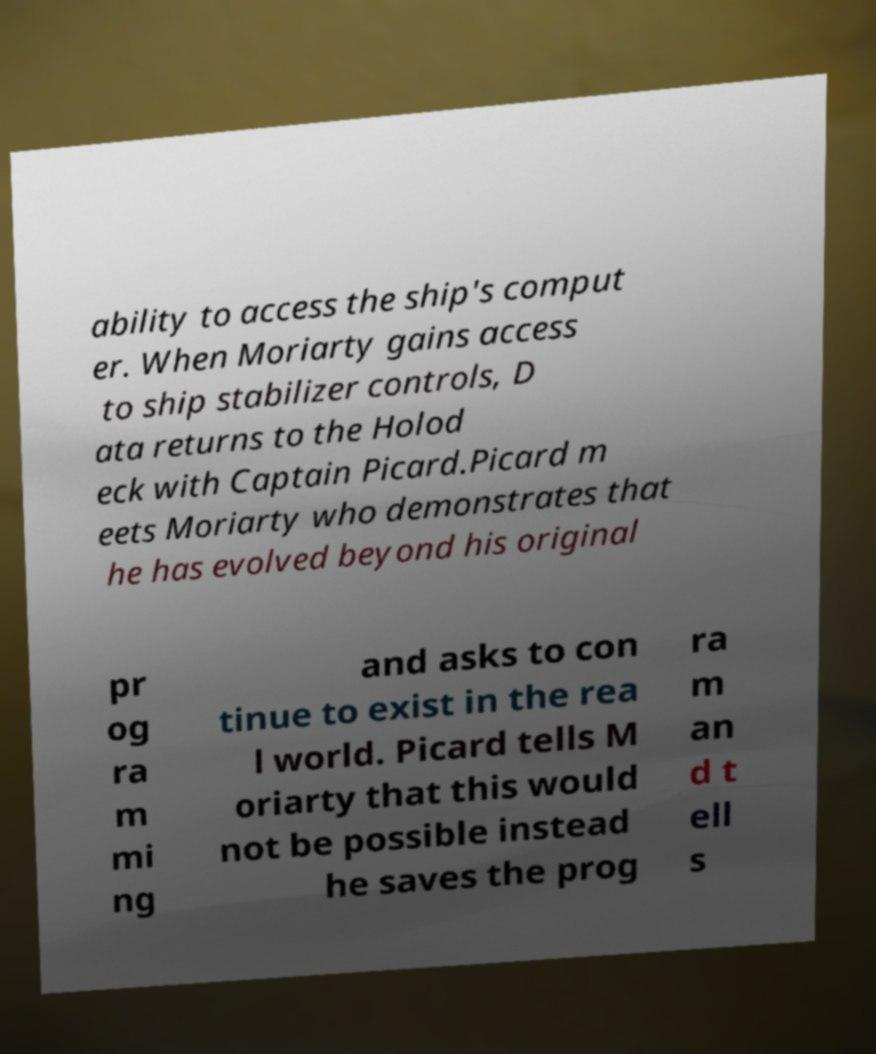What messages or text are displayed in this image? I need them in a readable, typed format. ability to access the ship's comput er. When Moriarty gains access to ship stabilizer controls, D ata returns to the Holod eck with Captain Picard.Picard m eets Moriarty who demonstrates that he has evolved beyond his original pr og ra m mi ng and asks to con tinue to exist in the rea l world. Picard tells M oriarty that this would not be possible instead he saves the prog ra m an d t ell s 